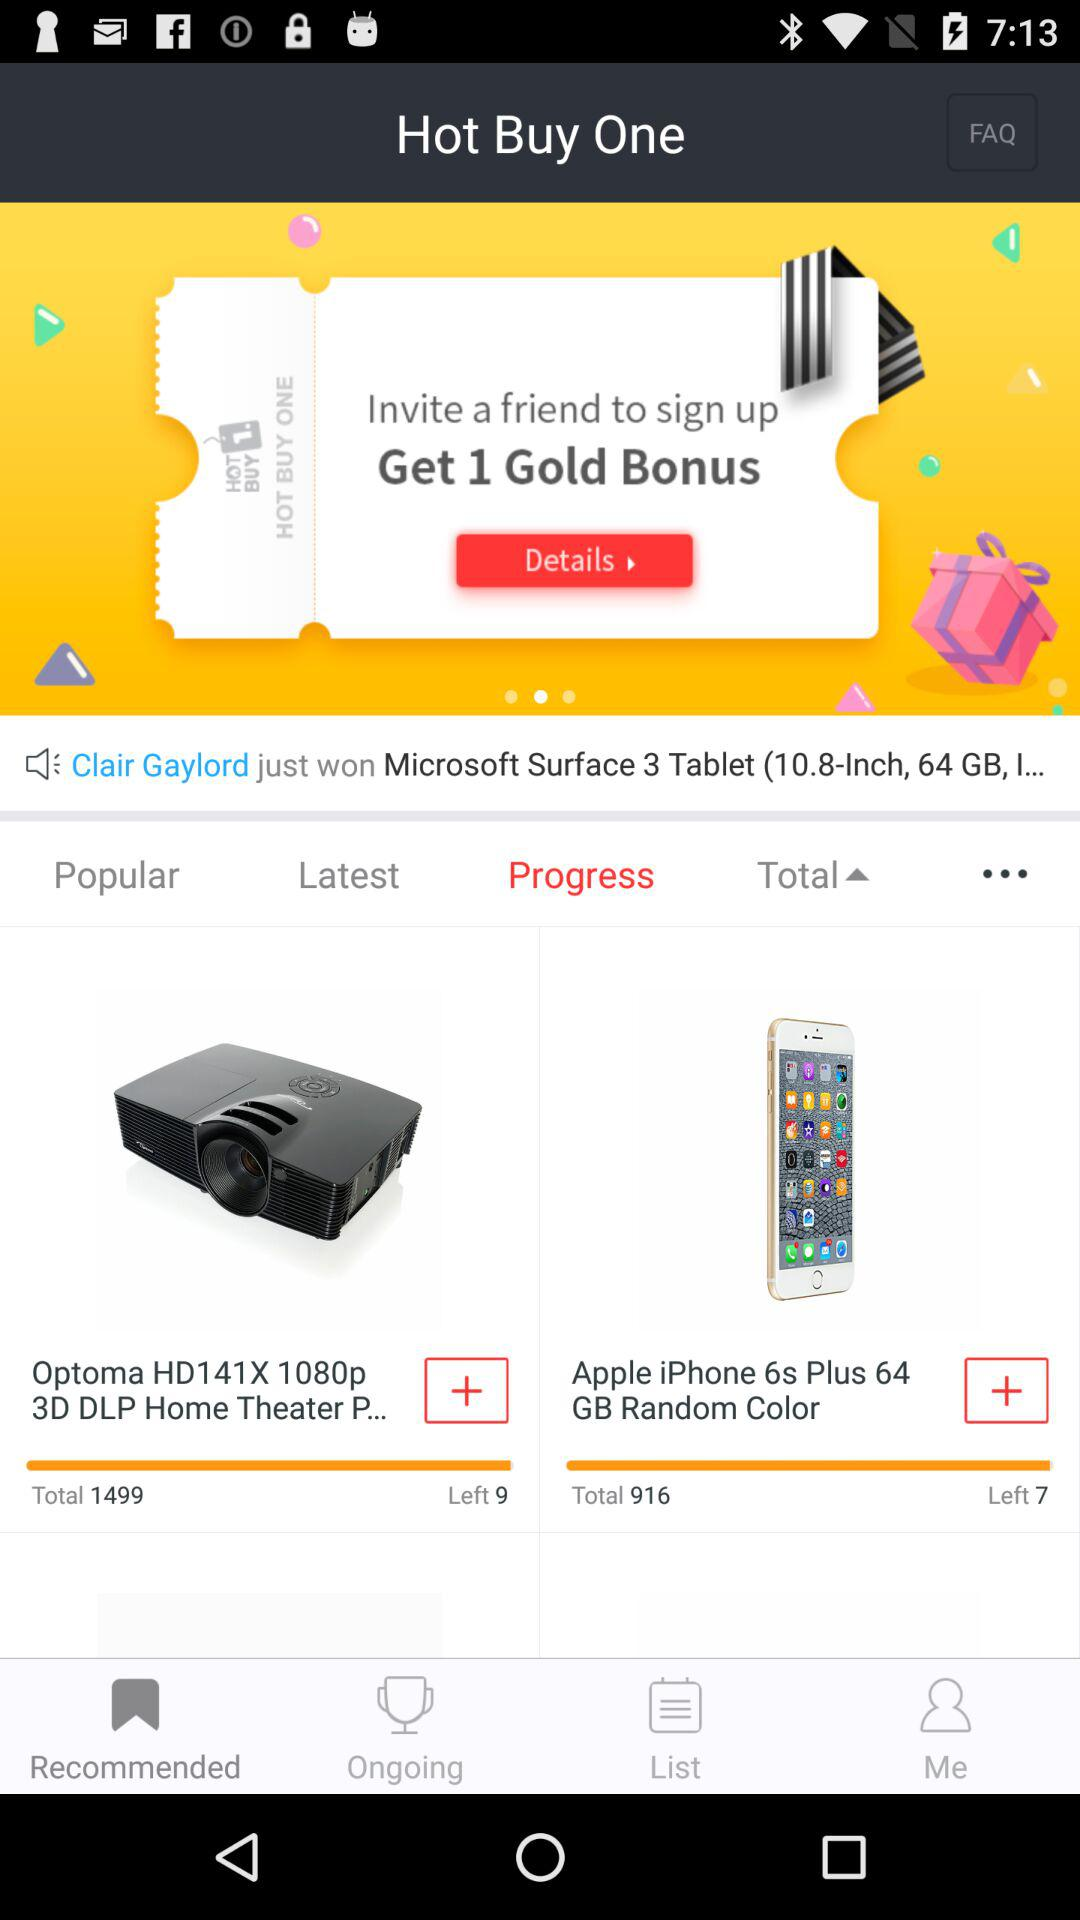How many phones are left? There are 7 phones left. 